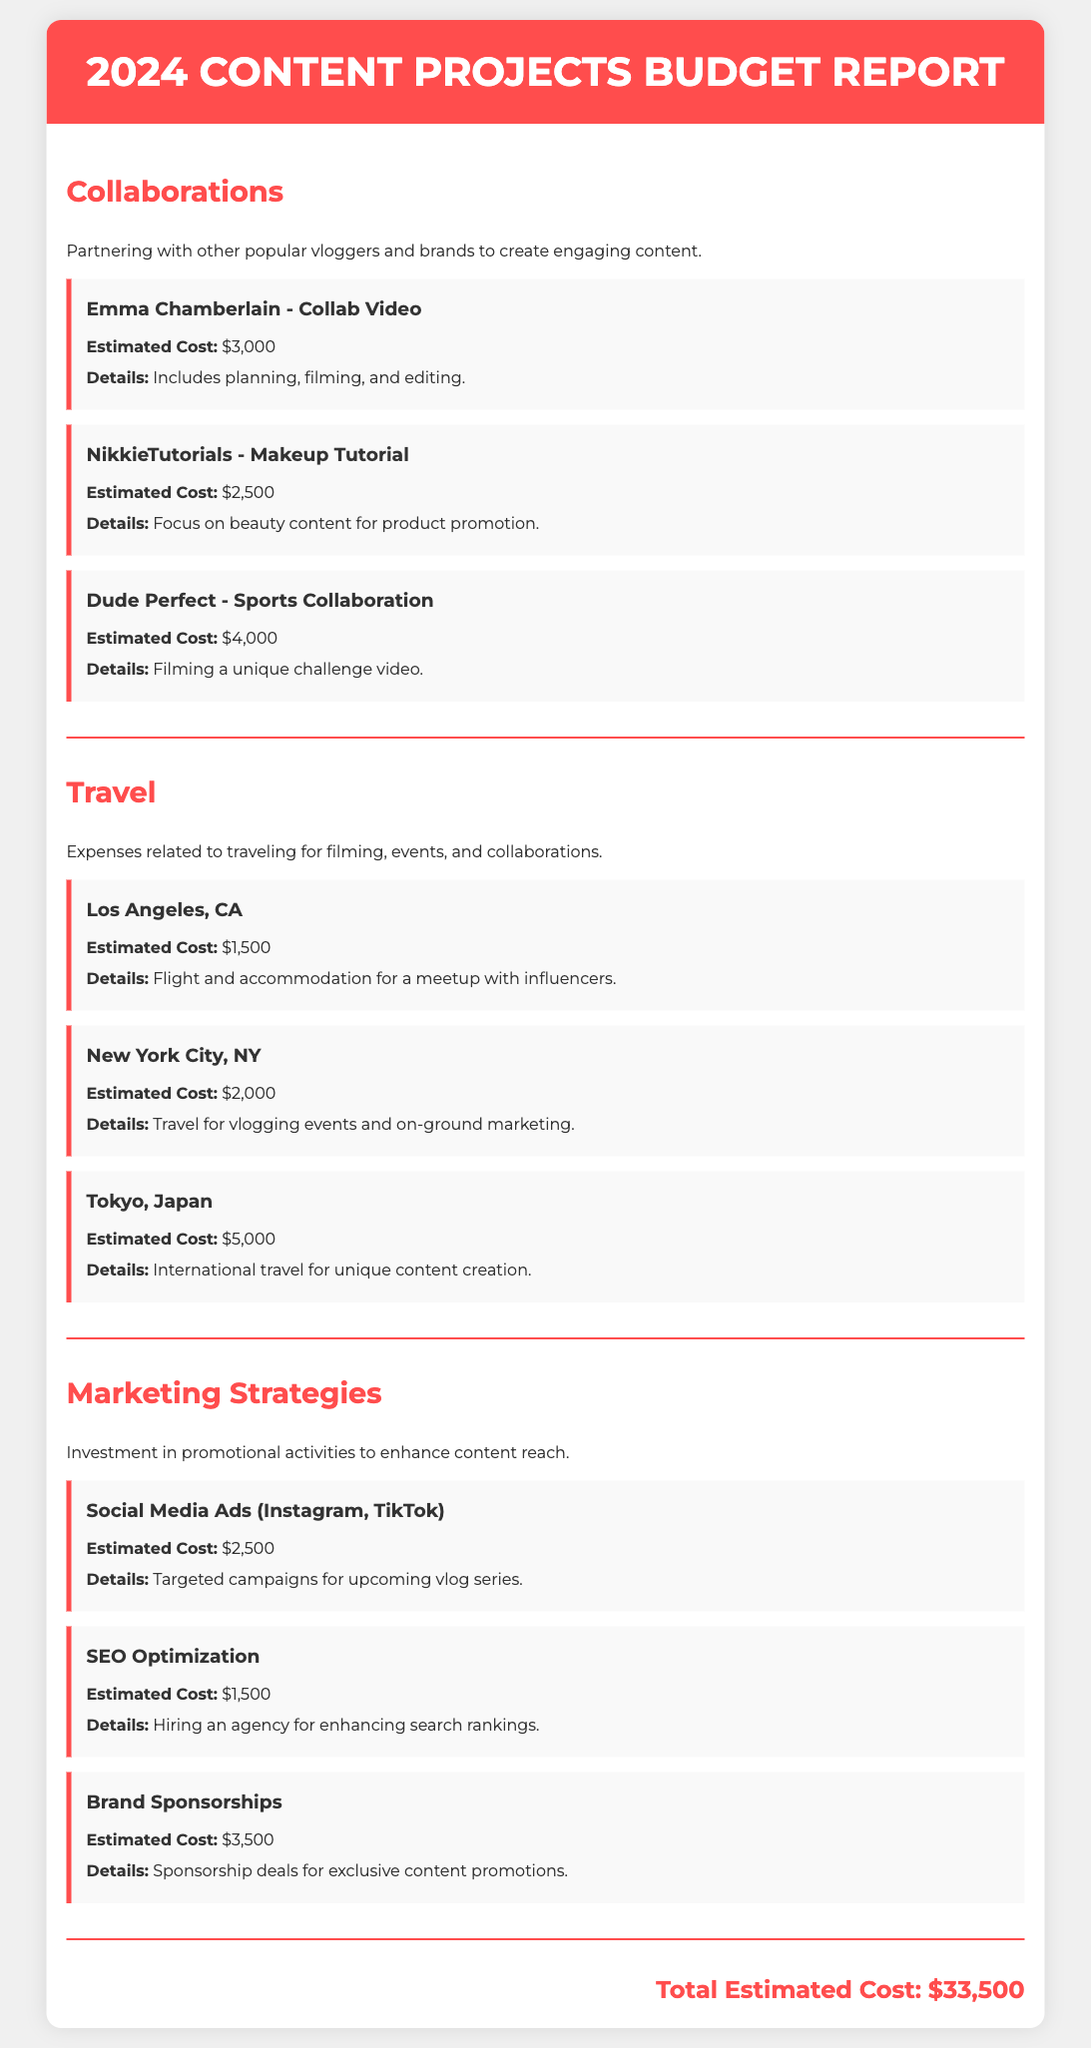What is the estimated cost for the collaboration with Emma Chamberlain? The estimated cost for the collaboration with Emma Chamberlain is provided in the document as $3,000.
Answer: $3,000 What is the total estimated cost for travel? The travel section lists individual estimated costs for travel, totaling $8,500 when summed.
Answer: $8,500 How much is allocated for social media ads? The document specifies that the estimated cost for social media ads is $2,500.
Answer: $2,500 Which city has the highest travel cost? The travel section reveals that Tokyo, Japan has the highest estimated travel cost of $5,000.
Answer: Tokyo, Japan What is the total estimated cost across all sections? The total estimated cost is directly mentioned at the bottom of the document as the sum of all project costs, which is $33,500.
Answer: $33,500 What type of content is the collaboration with Dude Perfect focused on? The collaboration with Dude Perfect is focused on sports content as indicated in the description.
Answer: Sports Which marketing strategy has the highest cost? The document indicates that brand sponsorships have the highest estimated cost of $3,500 in the marketing strategies section.
Answer: Brand Sponsorships How many collaborations are listed in the report? The document lists three collaborations under the collaborations section.
Answer: Three What is the estimated cost for SEO optimization? The estimated cost for SEO optimization is provided as $1,500 in the marketing strategies section.
Answer: $1,500 